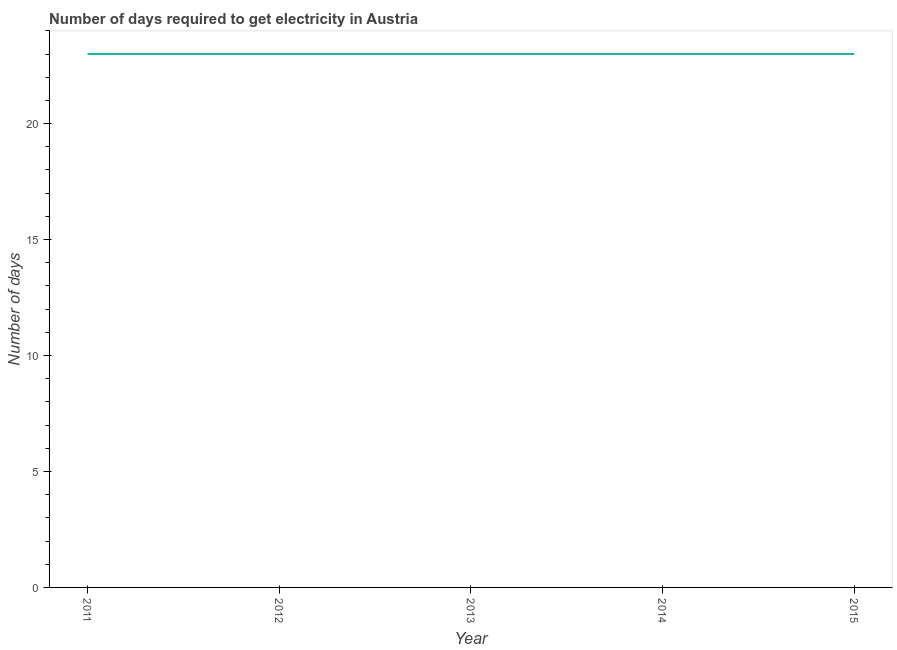What is the time to get electricity in 2015?
Ensure brevity in your answer.  23. Across all years, what is the maximum time to get electricity?
Your answer should be very brief. 23. Across all years, what is the minimum time to get electricity?
Provide a short and direct response. 23. In which year was the time to get electricity maximum?
Keep it short and to the point. 2011. What is the sum of the time to get electricity?
Make the answer very short. 115. What is the difference between the time to get electricity in 2013 and 2015?
Provide a succinct answer. 0. What is the average time to get electricity per year?
Offer a terse response. 23. Do a majority of the years between 2015 and 2014 (inclusive) have time to get electricity greater than 19 ?
Provide a succinct answer. No. What is the ratio of the time to get electricity in 2011 to that in 2013?
Your answer should be compact. 1. Is the time to get electricity in 2011 less than that in 2013?
Provide a short and direct response. No. Is the difference between the time to get electricity in 2014 and 2015 greater than the difference between any two years?
Offer a very short reply. Yes. What is the difference between the highest and the second highest time to get electricity?
Offer a terse response. 0. Is the sum of the time to get electricity in 2012 and 2014 greater than the maximum time to get electricity across all years?
Give a very brief answer. Yes. What is the difference between the highest and the lowest time to get electricity?
Offer a terse response. 0. In how many years, is the time to get electricity greater than the average time to get electricity taken over all years?
Provide a short and direct response. 0. Does the time to get electricity monotonically increase over the years?
Keep it short and to the point. No. How many lines are there?
Keep it short and to the point. 1. Are the values on the major ticks of Y-axis written in scientific E-notation?
Provide a succinct answer. No. Does the graph contain any zero values?
Your response must be concise. No. What is the title of the graph?
Give a very brief answer. Number of days required to get electricity in Austria. What is the label or title of the X-axis?
Your response must be concise. Year. What is the label or title of the Y-axis?
Your response must be concise. Number of days. What is the Number of days of 2012?
Provide a short and direct response. 23. What is the Number of days in 2013?
Offer a terse response. 23. What is the difference between the Number of days in 2011 and 2015?
Offer a very short reply. 0. What is the difference between the Number of days in 2013 and 2015?
Your answer should be compact. 0. What is the difference between the Number of days in 2014 and 2015?
Make the answer very short. 0. What is the ratio of the Number of days in 2011 to that in 2013?
Your answer should be very brief. 1. What is the ratio of the Number of days in 2011 to that in 2014?
Provide a succinct answer. 1. What is the ratio of the Number of days in 2012 to that in 2013?
Offer a terse response. 1. What is the ratio of the Number of days in 2012 to that in 2014?
Your response must be concise. 1. What is the ratio of the Number of days in 2012 to that in 2015?
Ensure brevity in your answer.  1. What is the ratio of the Number of days in 2013 to that in 2015?
Your answer should be very brief. 1. 